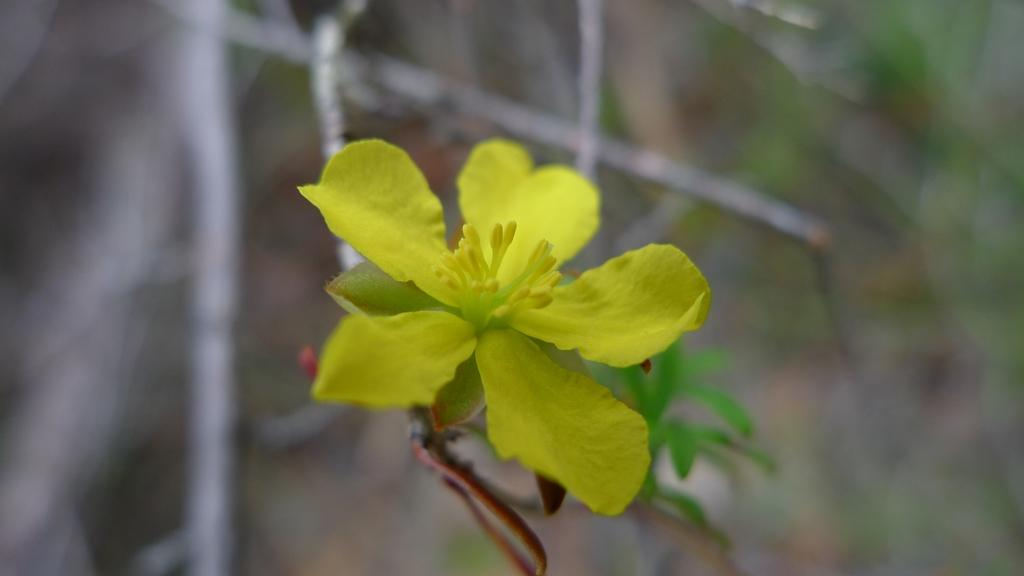What type of flower is present in the image? There is a yellow flower in the image. What other plant elements can be seen in the image? There are green leaves in the image. How would you describe the background of the image? The background of the image is blurred. What type of store can be seen in the background of the image? There is no store present in the image; the background is blurred. What selection of items is available in the image? The image only contains a yellow flower and green leaves, so there is no selection of items available. 